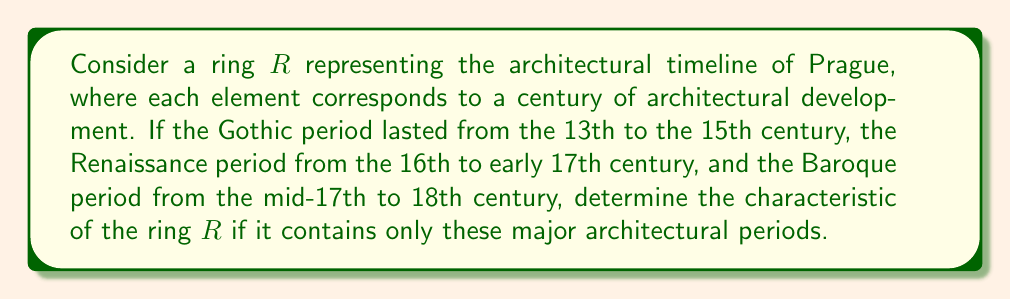Give your solution to this math problem. To solve this problem, we need to understand the concept of ring characteristic and how it relates to the given architectural periods in Prague's history.

1. First, let's identify the elements in our ring $R$:
   - Gothic period: 13th, 14th, 15th centuries (3 elements)
   - Renaissance period: 16th, early 17th centuries (2 elements)
   - Baroque period: mid-17th, 18th centuries (2 elements)

   Total elements in $R$: $3 + 2 + 2 = 7$

2. The characteristic of a ring is the smallest positive integer $n$ such that:

   $$n \cdot 1_R = 0_R$$

   Where $1_R$ is the multiplicative identity and $0_R$ is the additive identity of the ring.

3. In our case, we can think of addition in the ring as moving forward in time, and multiplication as repeating architectural styles.

4. Since our ring contains 7 elements (centuries), we can represent it as $\mathbb{Z}_7$, the ring of integers modulo 7.

5. In $\mathbb{Z}_7$, we have:

   $$7 \cdot 1 \equiv 0 \pmod{7}$$

6. This is the smallest positive integer that satisfies the condition for the characteristic.

Therefore, the characteristic of our ring $R$ is 7.
Answer: The characteristic of the ring $R$ representing Prague's major architectural periods is 7. 